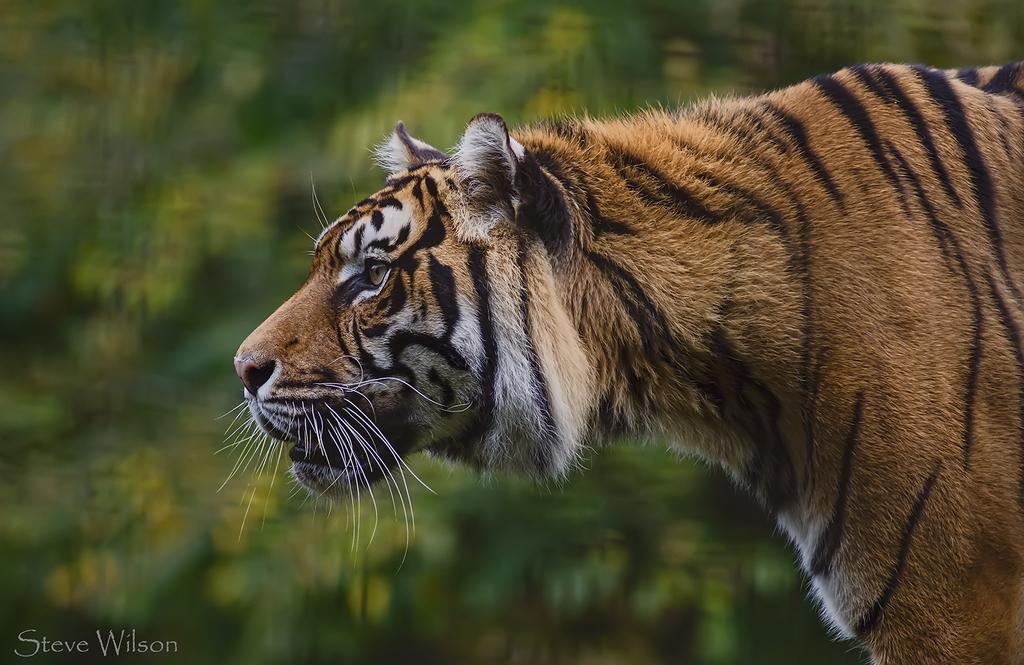What type of animal is in the image? There is an Indian tiger in the image. What color is the tiger? The tiger is brown in color. What can be seen in the background of the image? There are trees in the background of the image. What is the queen arguing with the worm about in the image? There is no queen or worm present in the image; it features an Indian tiger and trees in the background. 